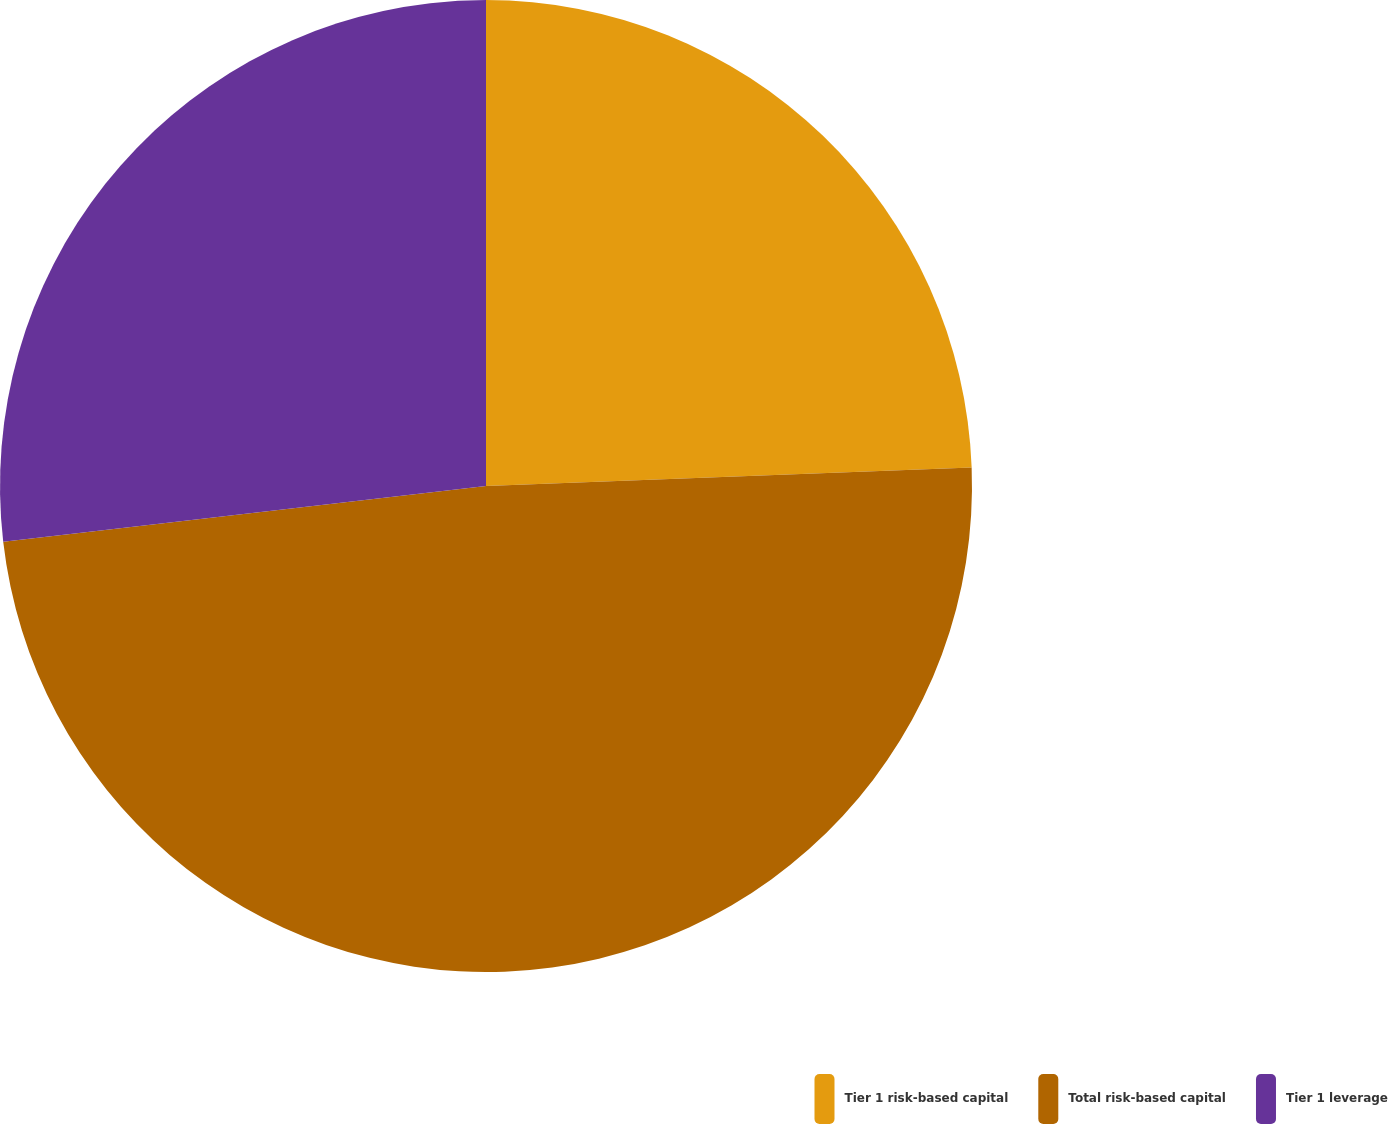<chart> <loc_0><loc_0><loc_500><loc_500><pie_chart><fcel>Tier 1 risk-based capital<fcel>Total risk-based capital<fcel>Tier 1 leverage<nl><fcel>24.39%<fcel>48.78%<fcel>26.83%<nl></chart> 